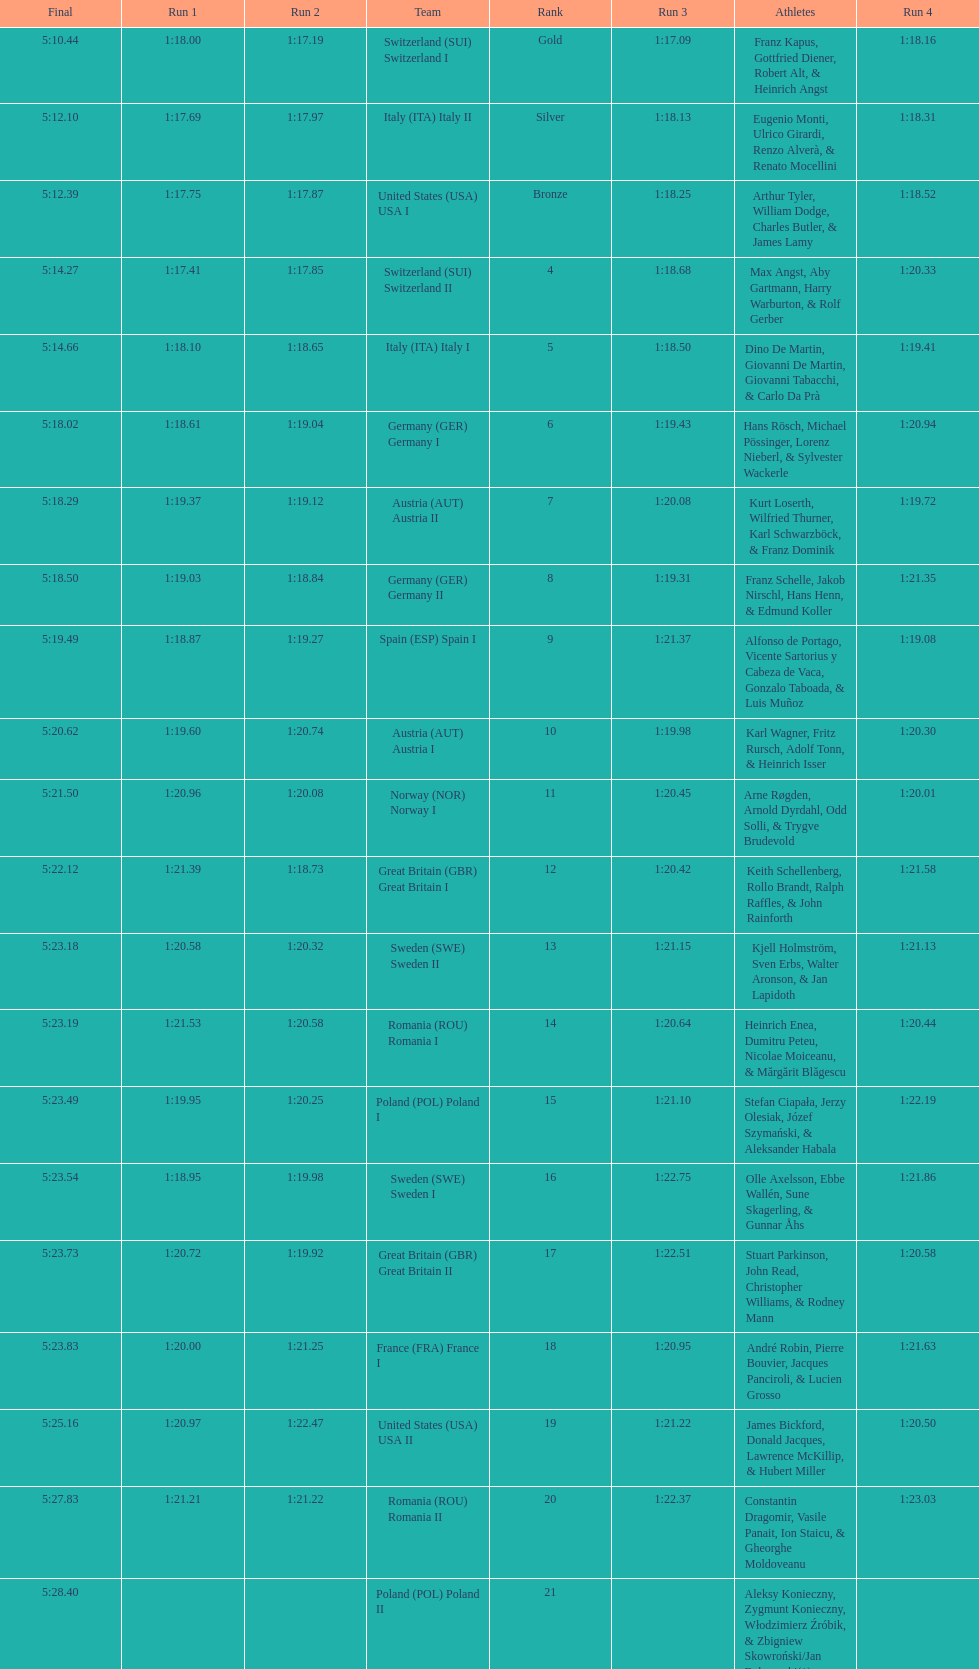Who is the previous team to italy (ita) italy ii? Switzerland (SUI) Switzerland I. Would you mind parsing the complete table? {'header': ['Final', 'Run 1', 'Run 2', 'Team', 'Rank', 'Run 3', 'Athletes', 'Run 4'], 'rows': [['5:10.44', '1:18.00', '1:17.19', 'Switzerland\xa0(SUI) Switzerland I', 'Gold', '1:17.09', 'Franz Kapus, Gottfried Diener, Robert Alt, & Heinrich Angst', '1:18.16'], ['5:12.10', '1:17.69', '1:17.97', 'Italy\xa0(ITA) Italy II', 'Silver', '1:18.13', 'Eugenio Monti, Ulrico Girardi, Renzo Alverà, & Renato Mocellini', '1:18.31'], ['5:12.39', '1:17.75', '1:17.87', 'United States\xa0(USA) USA I', 'Bronze', '1:18.25', 'Arthur Tyler, William Dodge, Charles Butler, & James Lamy', '1:18.52'], ['5:14.27', '1:17.41', '1:17.85', 'Switzerland\xa0(SUI) Switzerland II', '4', '1:18.68', 'Max Angst, Aby Gartmann, Harry Warburton, & Rolf Gerber', '1:20.33'], ['5:14.66', '1:18.10', '1:18.65', 'Italy\xa0(ITA) Italy I', '5', '1:18.50', 'Dino De Martin, Giovanni De Martin, Giovanni Tabacchi, & Carlo Da Prà', '1:19.41'], ['5:18.02', '1:18.61', '1:19.04', 'Germany\xa0(GER) Germany I', '6', '1:19.43', 'Hans Rösch, Michael Pössinger, Lorenz Nieberl, & Sylvester Wackerle', '1:20.94'], ['5:18.29', '1:19.37', '1:19.12', 'Austria\xa0(AUT) Austria II', '7', '1:20.08', 'Kurt Loserth, Wilfried Thurner, Karl Schwarzböck, & Franz Dominik', '1:19.72'], ['5:18.50', '1:19.03', '1:18.84', 'Germany\xa0(GER) Germany II', '8', '1:19.31', 'Franz Schelle, Jakob Nirschl, Hans Henn, & Edmund Koller', '1:21.35'], ['5:19.49', '1:18.87', '1:19.27', 'Spain\xa0(ESP) Spain I', '9', '1:21.37', 'Alfonso de Portago, Vicente Sartorius y Cabeza de Vaca, Gonzalo Taboada, & Luis Muñoz', '1:19.08'], ['5:20.62', '1:19.60', '1:20.74', 'Austria\xa0(AUT) Austria I', '10', '1:19.98', 'Karl Wagner, Fritz Rursch, Adolf Tonn, & Heinrich Isser', '1:20.30'], ['5:21.50', '1:20.96', '1:20.08', 'Norway\xa0(NOR) Norway I', '11', '1:20.45', 'Arne Røgden, Arnold Dyrdahl, Odd Solli, & Trygve Brudevold', '1:20.01'], ['5:22.12', '1:21.39', '1:18.73', 'Great Britain\xa0(GBR) Great Britain I', '12', '1:20.42', 'Keith Schellenberg, Rollo Brandt, Ralph Raffles, & John Rainforth', '1:21.58'], ['5:23.18', '1:20.58', '1:20.32', 'Sweden\xa0(SWE) Sweden II', '13', '1:21.15', 'Kjell Holmström, Sven Erbs, Walter Aronson, & Jan Lapidoth', '1:21.13'], ['5:23.19', '1:21.53', '1:20.58', 'Romania\xa0(ROU) Romania I', '14', '1:20.64', 'Heinrich Enea, Dumitru Peteu, Nicolae Moiceanu, & Mărgărit Blăgescu', '1:20.44'], ['5:23.49', '1:19.95', '1:20.25', 'Poland\xa0(POL) Poland I', '15', '1:21.10', 'Stefan Ciapała, Jerzy Olesiak, Józef Szymański, & Aleksander Habala', '1:22.19'], ['5:23.54', '1:18.95', '1:19.98', 'Sweden\xa0(SWE) Sweden I', '16', '1:22.75', 'Olle Axelsson, Ebbe Wallén, Sune Skagerling, & Gunnar Åhs', '1:21.86'], ['5:23.73', '1:20.72', '1:19.92', 'Great Britain\xa0(GBR) Great Britain II', '17', '1:22.51', 'Stuart Parkinson, John Read, Christopher Williams, & Rodney Mann', '1:20.58'], ['5:23.83', '1:20.00', '1:21.25', 'France\xa0(FRA) France I', '18', '1:20.95', 'André Robin, Pierre Bouvier, Jacques Panciroli, & Lucien Grosso', '1:21.63'], ['5:25.16', '1:20.97', '1:22.47', 'United States\xa0(USA) USA II', '19', '1:21.22', 'James Bickford, Donald Jacques, Lawrence McKillip, & Hubert Miller', '1:20.50'], ['5:27.83', '1:21.21', '1:21.22', 'Romania\xa0(ROU) Romania II', '20', '1:22.37', 'Constantin Dragomir, Vasile Panait, Ion Staicu, & Gheorghe Moldoveanu', '1:23.03'], ['5:28.40', '', '', 'Poland\xa0(POL) Poland II', '21', '', 'Aleksy Konieczny, Zygmunt Konieczny, Włodzimierz Źróbik, & Zbigniew Skowroński/Jan Dąbrowski(*)', '']]} 